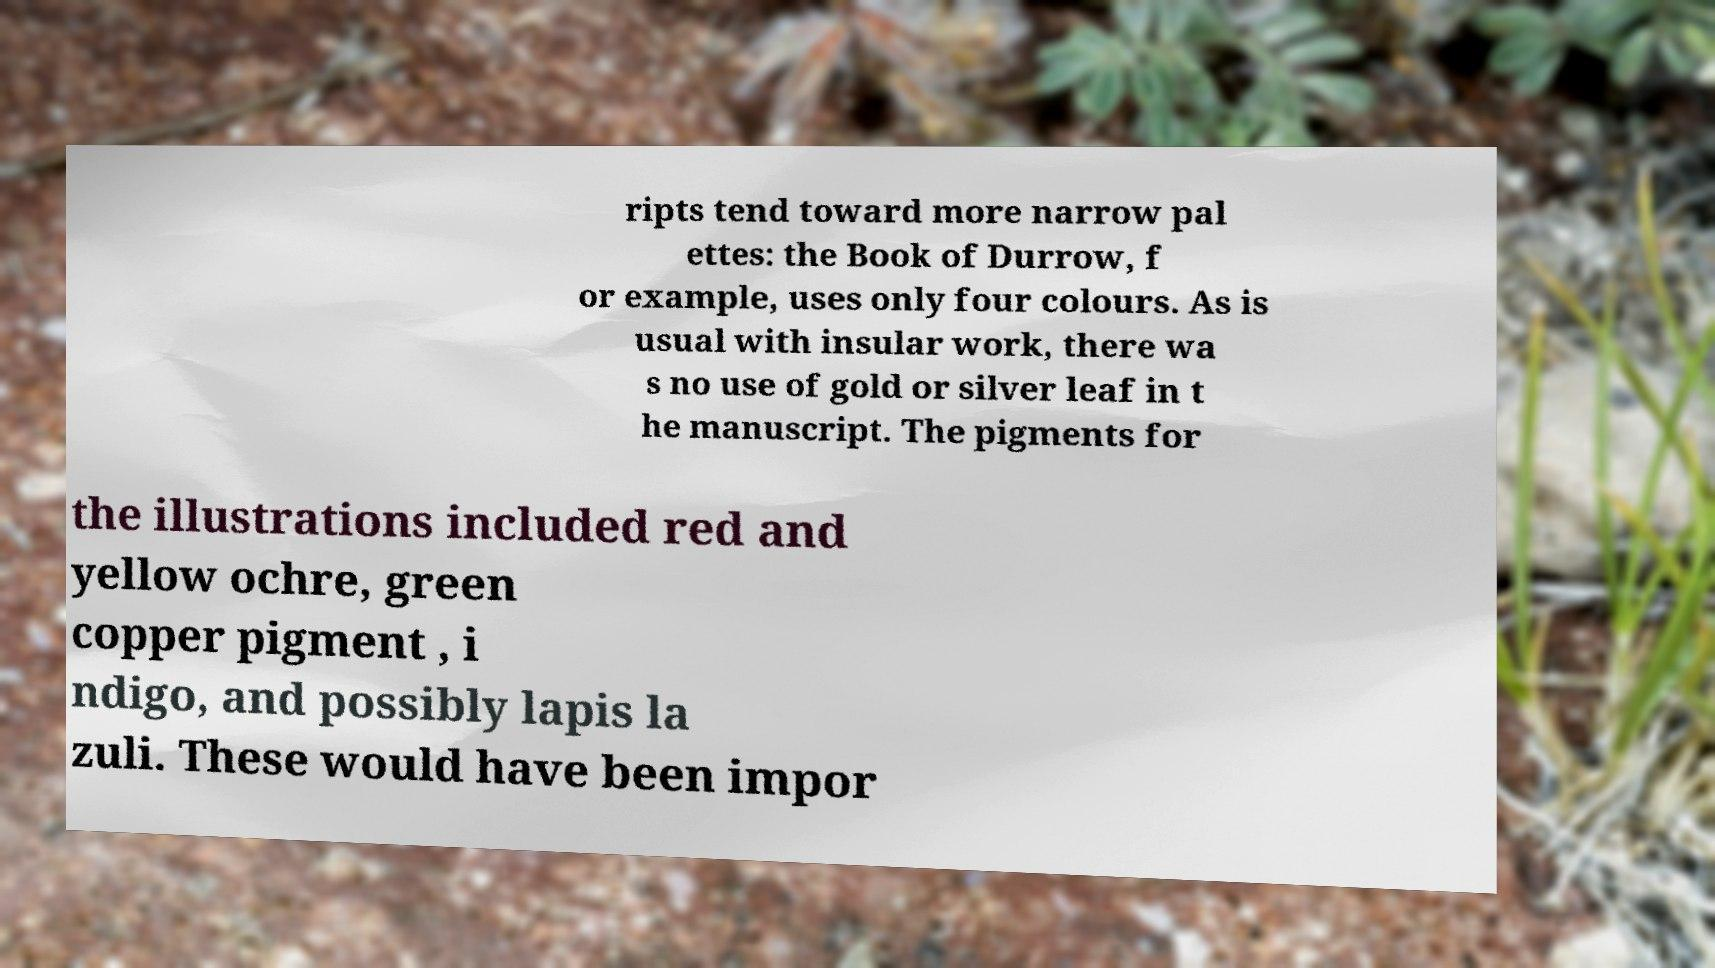For documentation purposes, I need the text within this image transcribed. Could you provide that? ripts tend toward more narrow pal ettes: the Book of Durrow, f or example, uses only four colours. As is usual with insular work, there wa s no use of gold or silver leaf in t he manuscript. The pigments for the illustrations included red and yellow ochre, green copper pigment , i ndigo, and possibly lapis la zuli. These would have been impor 